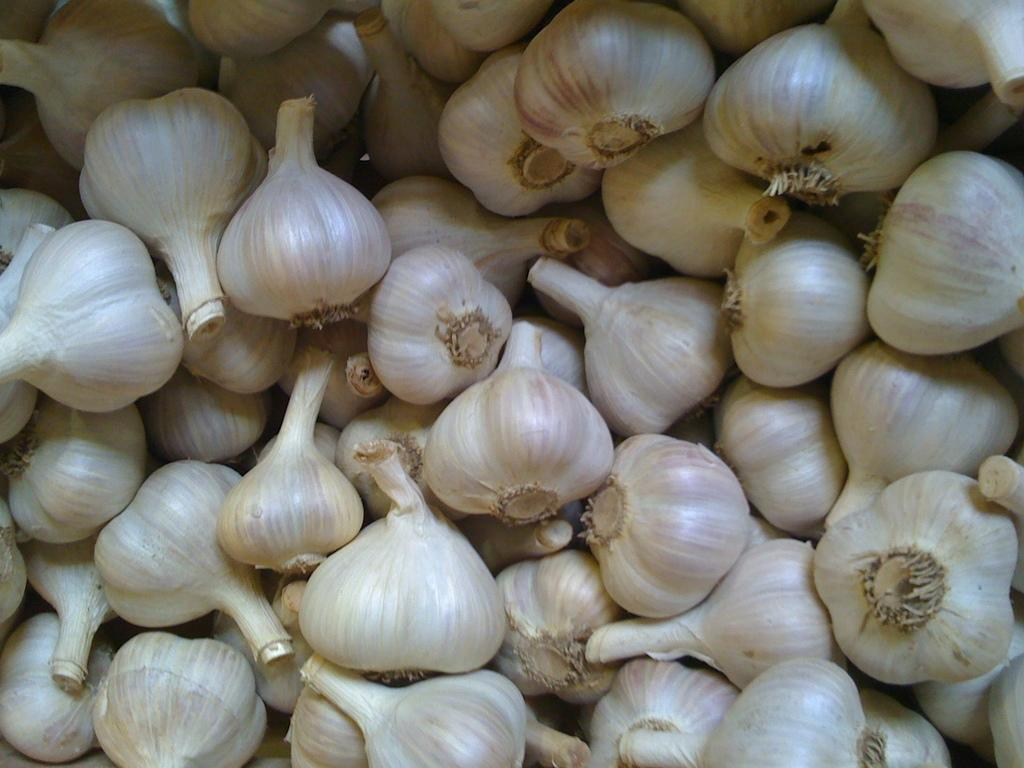What type of food item is present in the image? There is a group of white color garlic in the image. What is the color of the garlic? The garlic is white in color. What subject is the group of garlic teaching in the image? There is no indication in the image that the garlic is teaching any subject. Is there a collar visible on any of the garlic in the image? There is no collar present on any of the garlic in the image, as garlic is a vegetable and does not wear collars. 